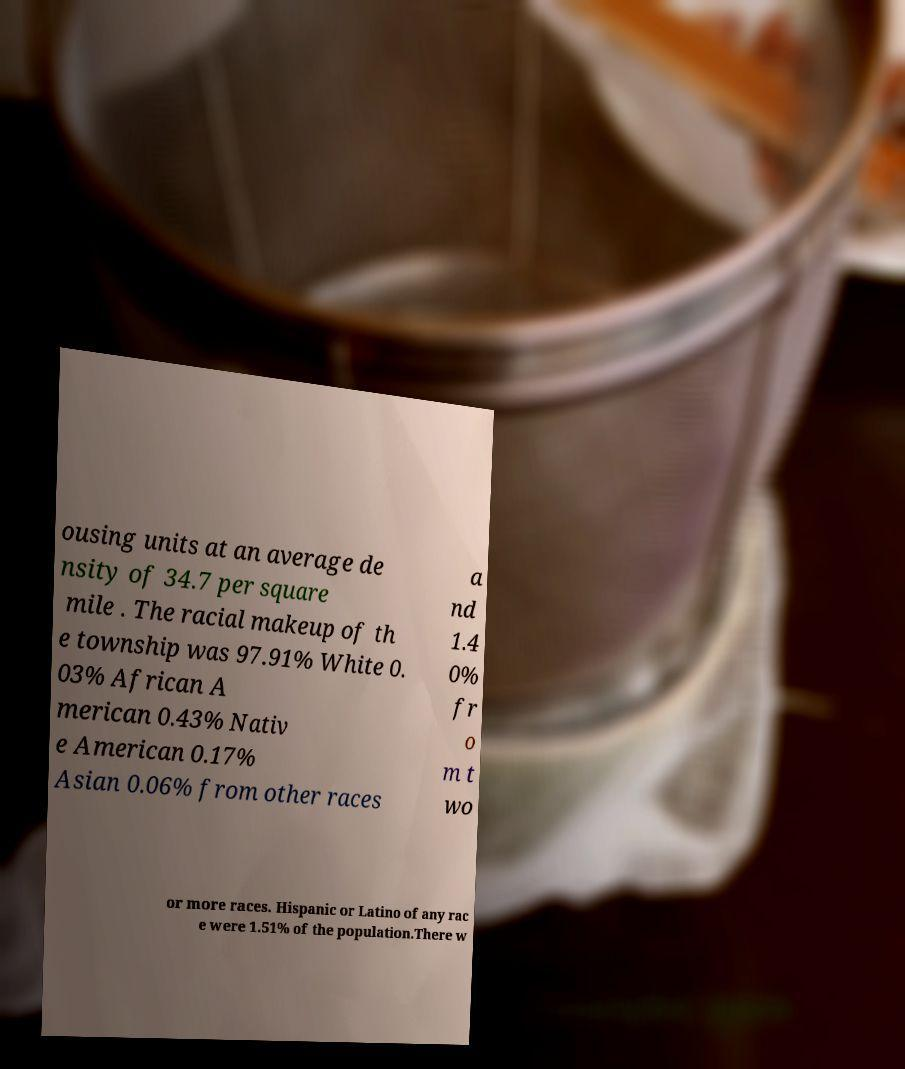There's text embedded in this image that I need extracted. Can you transcribe it verbatim? ousing units at an average de nsity of 34.7 per square mile . The racial makeup of th e township was 97.91% White 0. 03% African A merican 0.43% Nativ e American 0.17% Asian 0.06% from other races a nd 1.4 0% fr o m t wo or more races. Hispanic or Latino of any rac e were 1.51% of the population.There w 